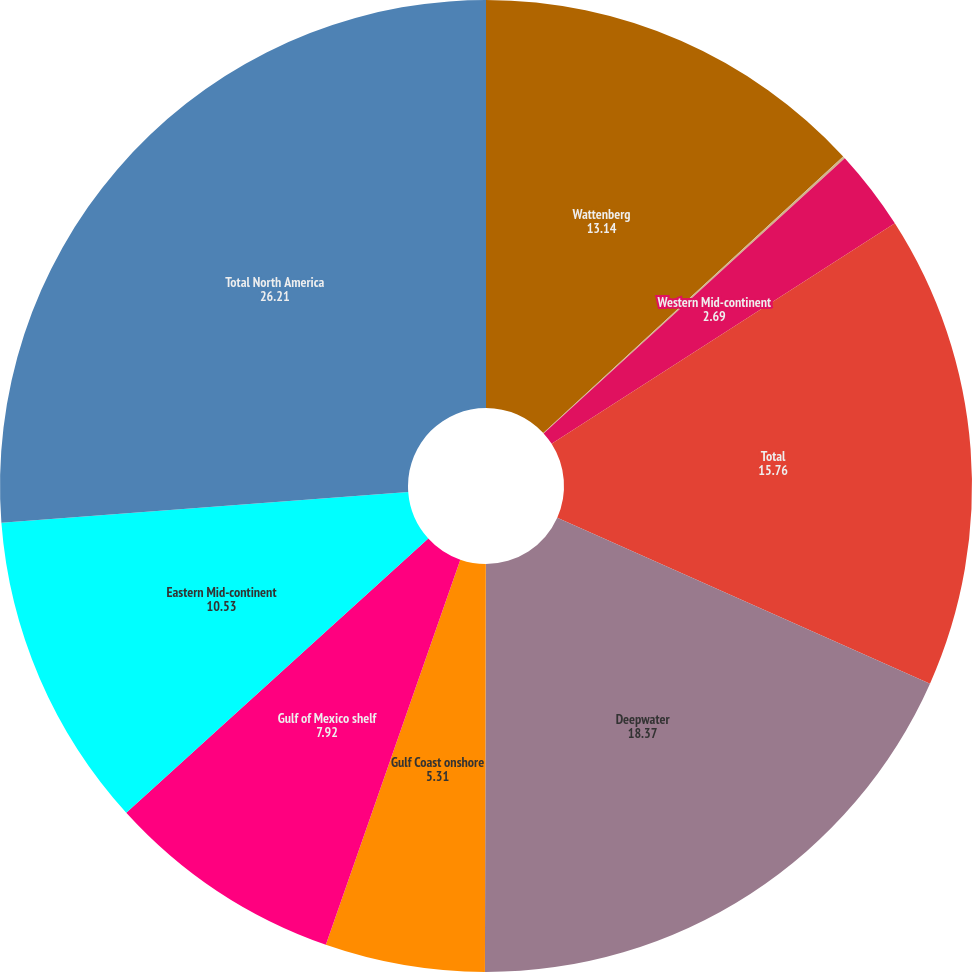Convert chart. <chart><loc_0><loc_0><loc_500><loc_500><pie_chart><fcel>Wattenberg<fcel>Other<fcel>Western Mid-continent<fcel>Total<fcel>Deepwater<fcel>Gulf Coast onshore<fcel>Gulf of Mexico shelf<fcel>Eastern Mid-continent<fcel>Total North America<nl><fcel>13.14%<fcel>0.08%<fcel>2.69%<fcel>15.76%<fcel>18.37%<fcel>5.31%<fcel>7.92%<fcel>10.53%<fcel>26.21%<nl></chart> 